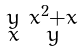Convert formula to latex. <formula><loc_0><loc_0><loc_500><loc_500>\begin{smallmatrix} y & x ^ { 2 } + x \\ x & y \end{smallmatrix}</formula> 